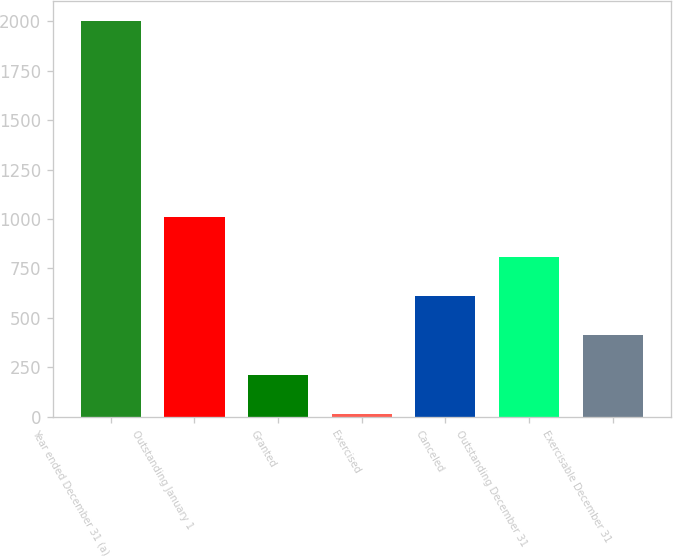Convert chart to OTSL. <chart><loc_0><loc_0><loc_500><loc_500><bar_chart><fcel>Year ended December 31 (a)<fcel>Outstanding January 1<fcel>Granted<fcel>Exercised<fcel>Canceled<fcel>Outstanding December 31<fcel>Exercisable December 31<nl><fcel>2003<fcel>1008.32<fcel>212.6<fcel>13.67<fcel>610.46<fcel>809.39<fcel>411.53<nl></chart> 